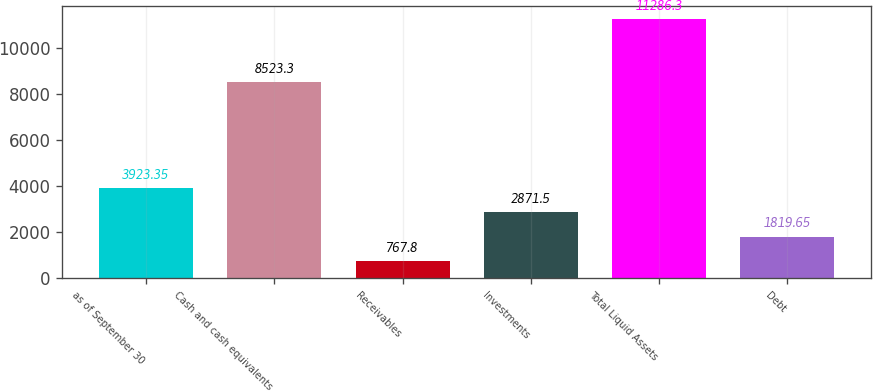Convert chart. <chart><loc_0><loc_0><loc_500><loc_500><bar_chart><fcel>as of September 30<fcel>Cash and cash equivalents<fcel>Receivables<fcel>Investments<fcel>Total Liquid Assets<fcel>Debt<nl><fcel>3923.35<fcel>8523.3<fcel>767.8<fcel>2871.5<fcel>11286.3<fcel>1819.65<nl></chart> 